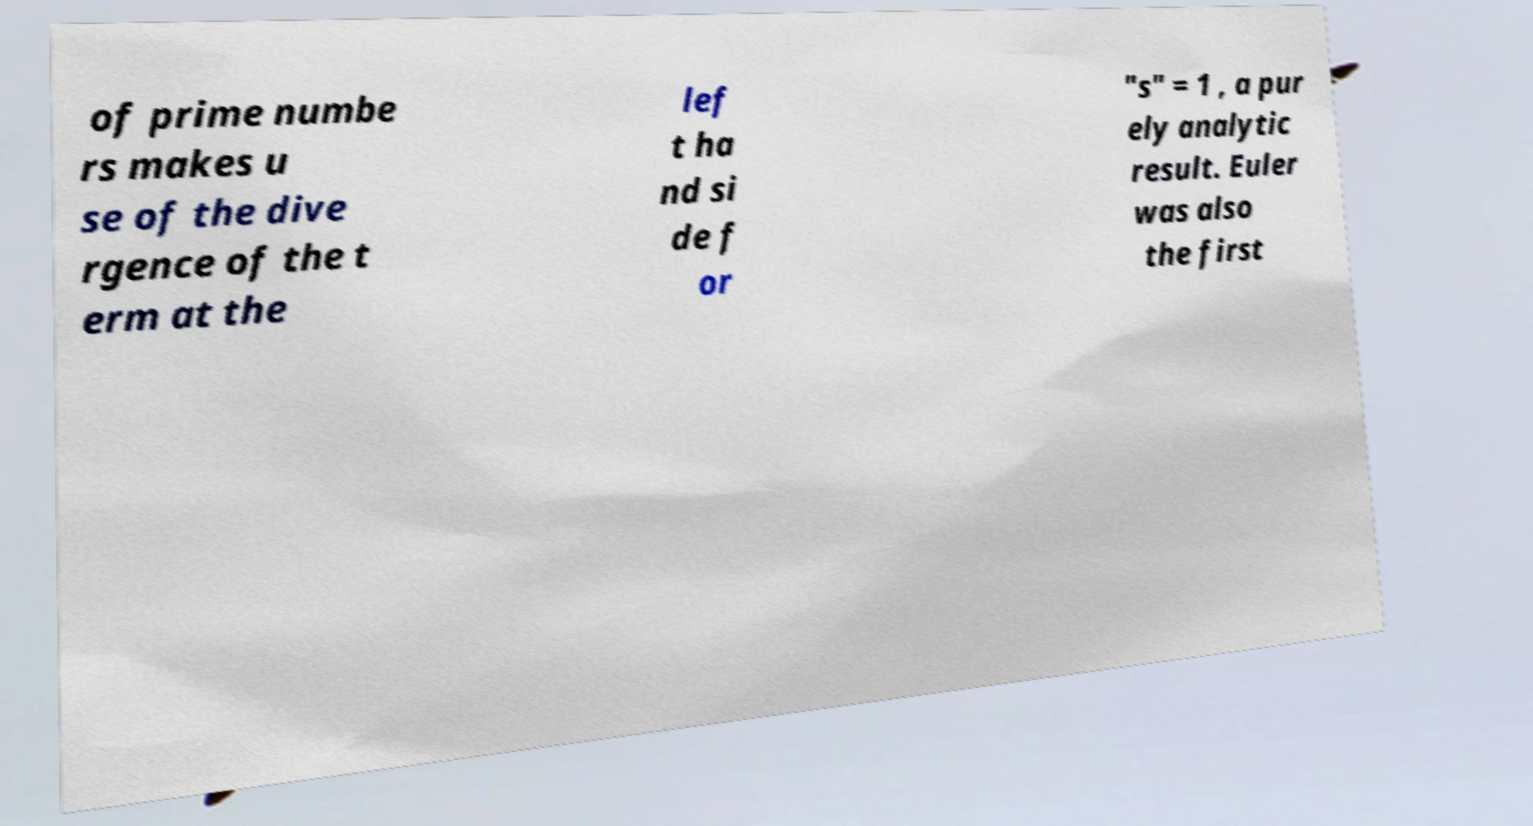Please identify and transcribe the text found in this image. of prime numbe rs makes u se of the dive rgence of the t erm at the lef t ha nd si de f or "s" = 1 , a pur ely analytic result. Euler was also the first 